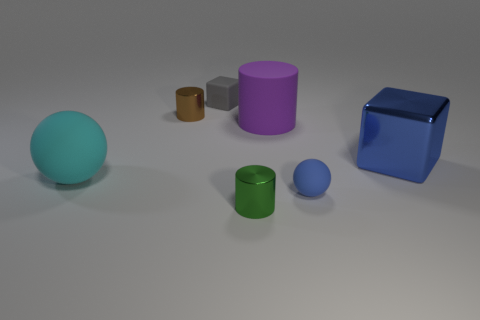Add 3 blocks. How many objects exist? 10 Subtract all cylinders. How many objects are left? 4 Add 1 big cyan metal objects. How many big cyan metal objects exist? 1 Subtract 1 blue blocks. How many objects are left? 6 Subtract all shiny things. Subtract all green objects. How many objects are left? 3 Add 1 green cylinders. How many green cylinders are left? 2 